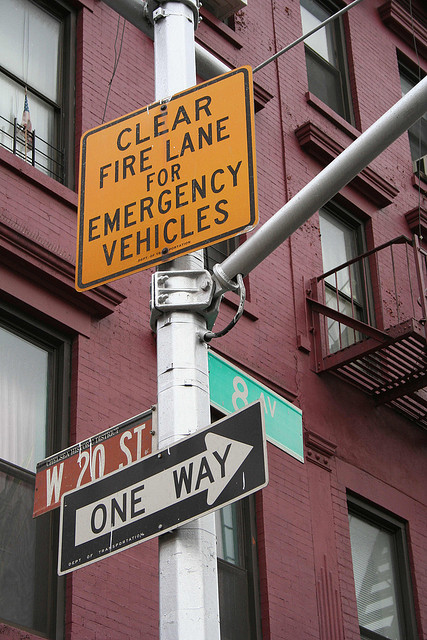Read all the text in this image. VEHICLES EMERGENCY CLEAR FIRE LANE FOR W ST WAY ONE 8 